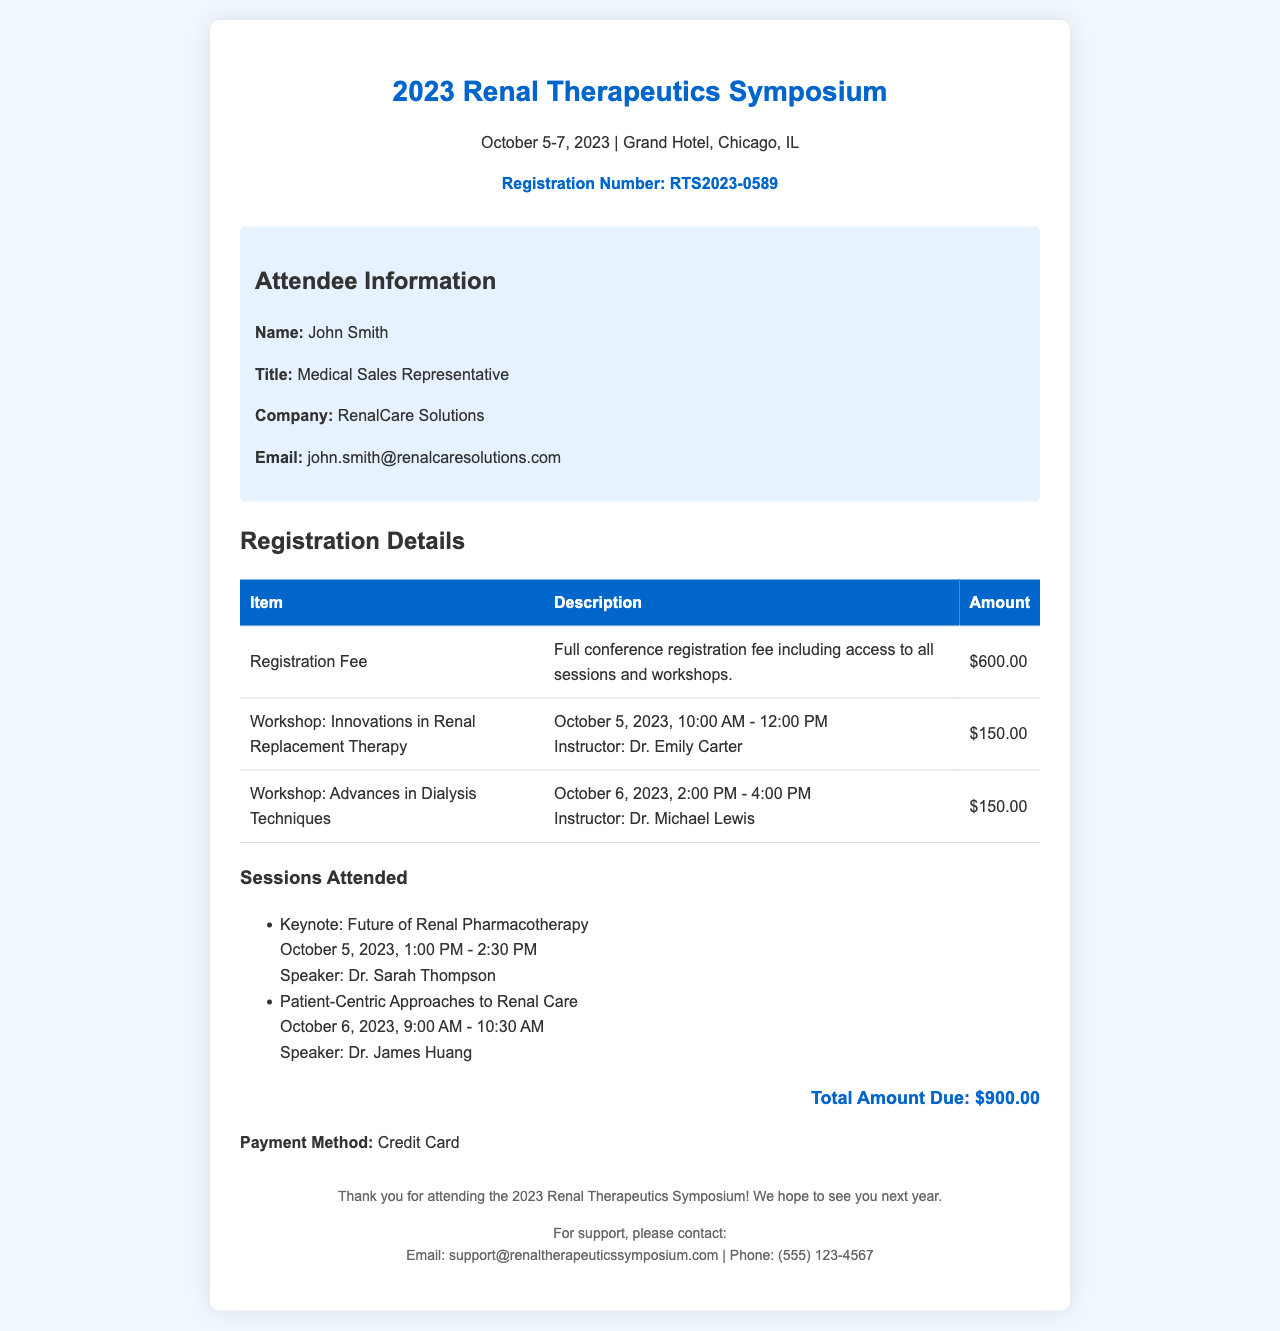what is the registration number? The registration number is listed under the header of the document, specifically labeled as "Registration Number."
Answer: RTS2023-0589 who is the attendee? The attendee's information is provided in a dedicated section titled "Attendee Information."
Answer: John Smith what is the total amount due? The total amount due is clearly indicated in the "breakdown" section of the document.
Answer: $900.00 when does the symposium take place? The dates of the symposium are mentioned under the title at the top of the document.
Answer: October 5-7, 2023 how much is the registration fee? The registration fee amount is provided in the breakdown table.
Answer: $600.00 who is the instructor for the "Innovations in Renal Replacement Therapy" workshop? The instructor for this workshop is listed in the description row of the breakdown table.
Answer: Dr. Emily Carter how many sessions did the attendee participate in? The number of sessions attended is inferred from the list of sessions presented in the document.
Answer: 2 what payment method was used? The payment method is mentioned at the end of the breakdown section.
Answer: Credit Card which workshop is scheduled on October 6, 2023? The scheduled workshop on this date is included in the breakdown table.
Answer: Advances in Dialysis Techniques 